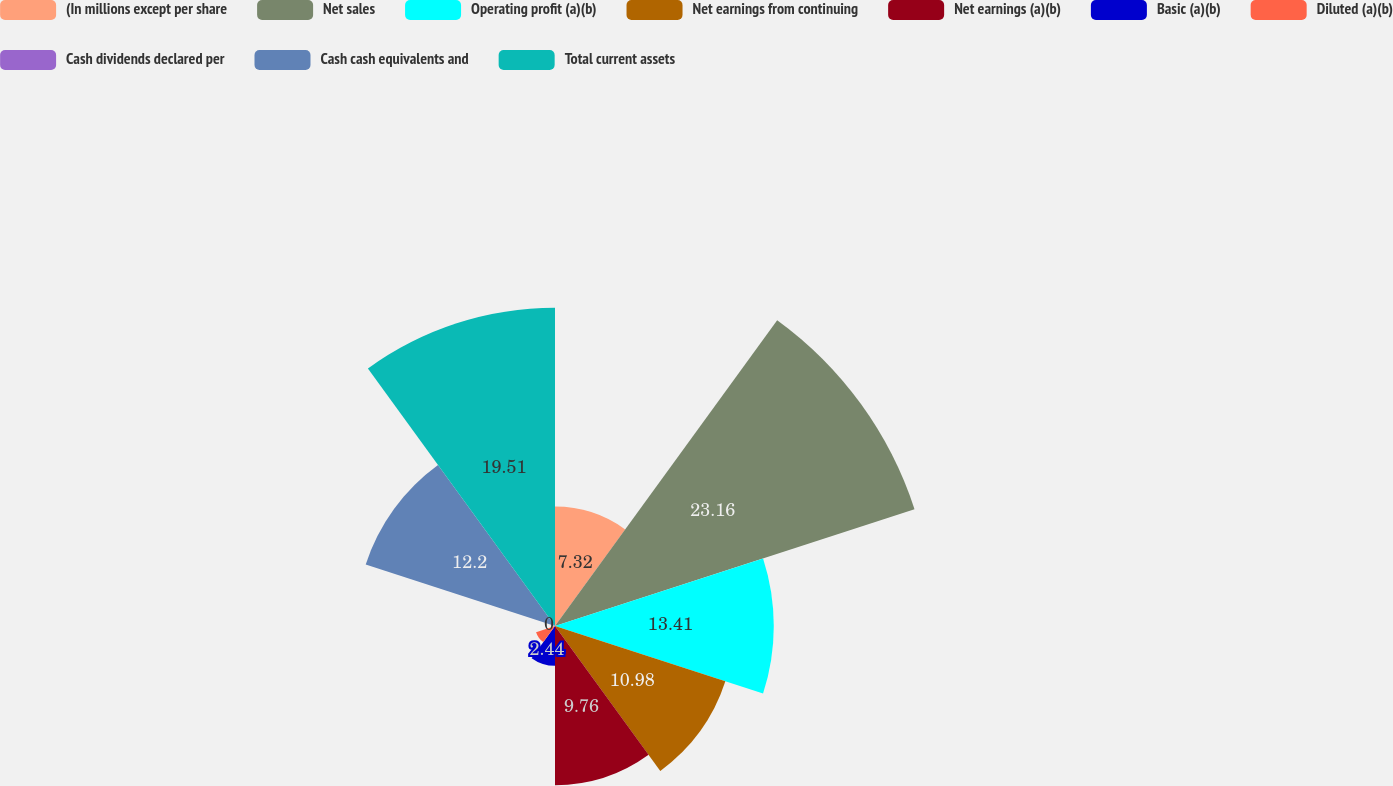<chart> <loc_0><loc_0><loc_500><loc_500><pie_chart><fcel>(In millions except per share<fcel>Net sales<fcel>Operating profit (a)(b)<fcel>Net earnings from continuing<fcel>Net earnings (a)(b)<fcel>Basic (a)(b)<fcel>Diluted (a)(b)<fcel>Cash dividends declared per<fcel>Cash cash equivalents and<fcel>Total current assets<nl><fcel>7.32%<fcel>23.17%<fcel>13.41%<fcel>10.98%<fcel>9.76%<fcel>2.44%<fcel>1.22%<fcel>0.0%<fcel>12.2%<fcel>19.51%<nl></chart> 